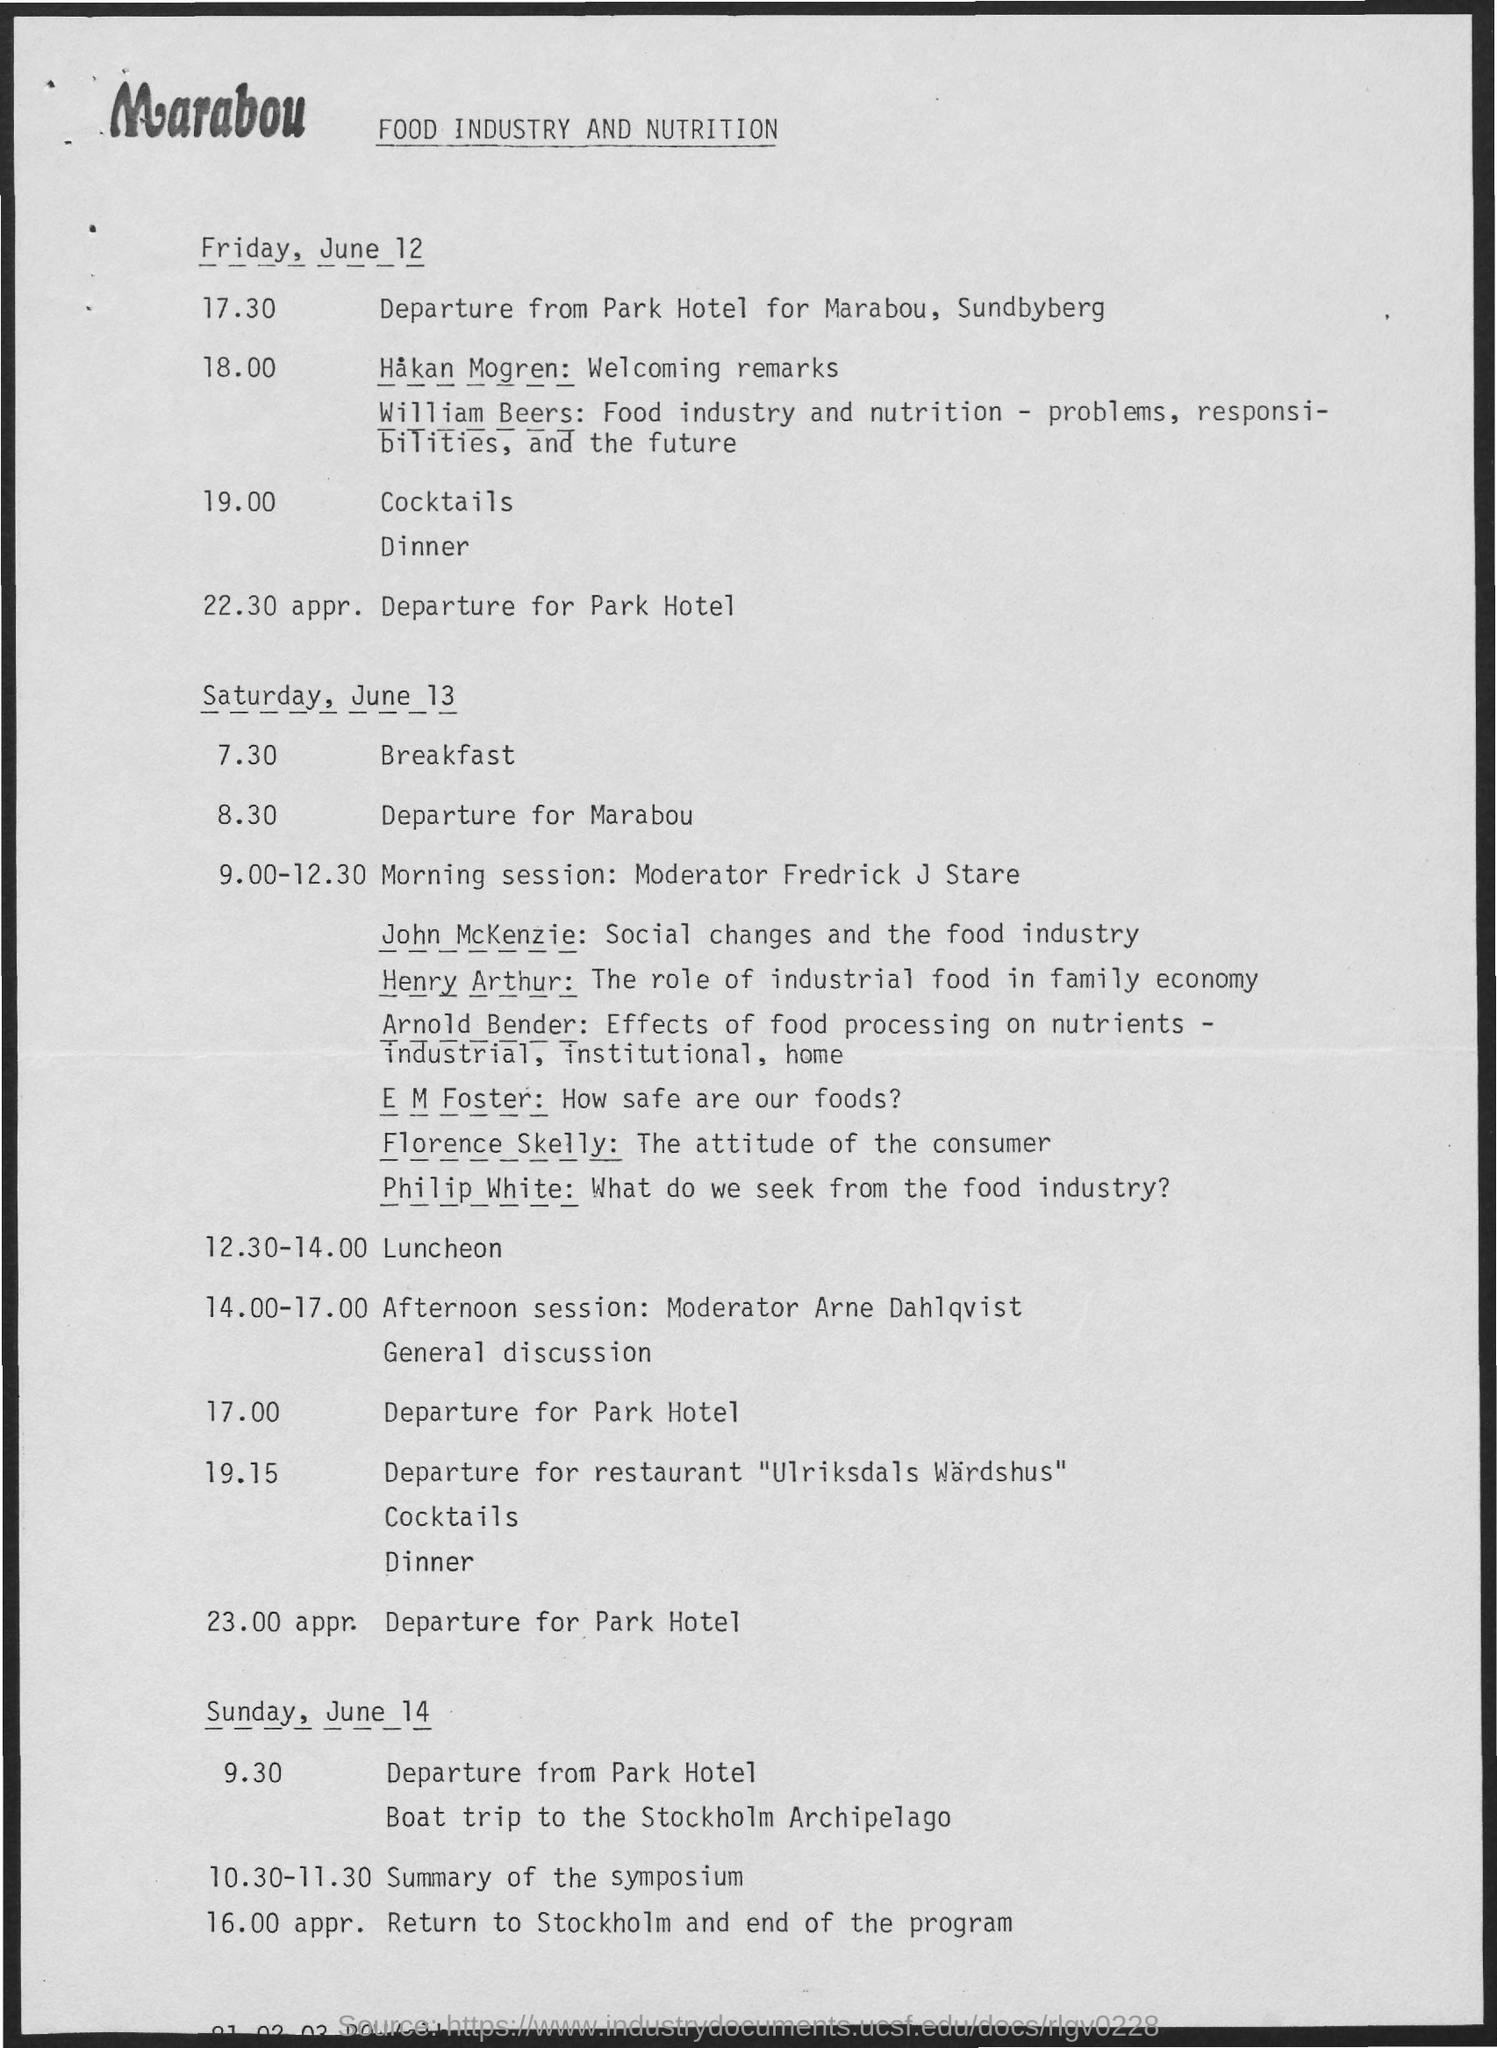Identify some key points in this picture. The departure for Park Hotel on Friday, June 12 is scheduled for 22:30 approximately. The summary of the symposium was held on Sunday, June 14, from 10:30 to 11:30. The return to Stockholm and the conclusion of the program will occur on Sunday, June 14. 